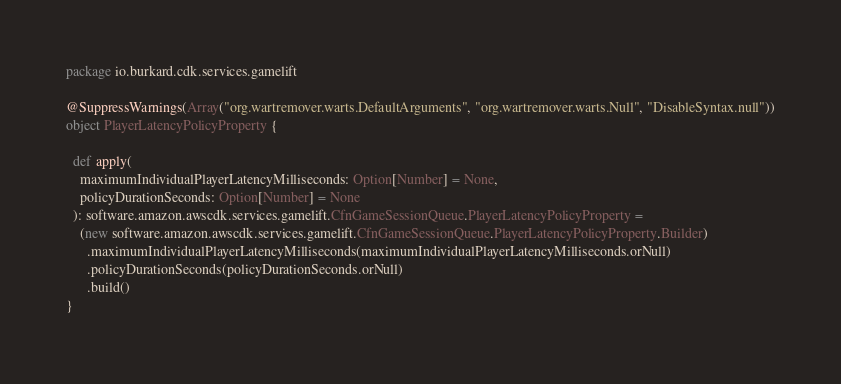Convert code to text. <code><loc_0><loc_0><loc_500><loc_500><_Scala_>package io.burkard.cdk.services.gamelift

@SuppressWarnings(Array("org.wartremover.warts.DefaultArguments", "org.wartremover.warts.Null", "DisableSyntax.null"))
object PlayerLatencyPolicyProperty {

  def apply(
    maximumIndividualPlayerLatencyMilliseconds: Option[Number] = None,
    policyDurationSeconds: Option[Number] = None
  ): software.amazon.awscdk.services.gamelift.CfnGameSessionQueue.PlayerLatencyPolicyProperty =
    (new software.amazon.awscdk.services.gamelift.CfnGameSessionQueue.PlayerLatencyPolicyProperty.Builder)
      .maximumIndividualPlayerLatencyMilliseconds(maximumIndividualPlayerLatencyMilliseconds.orNull)
      .policyDurationSeconds(policyDurationSeconds.orNull)
      .build()
}
</code> 